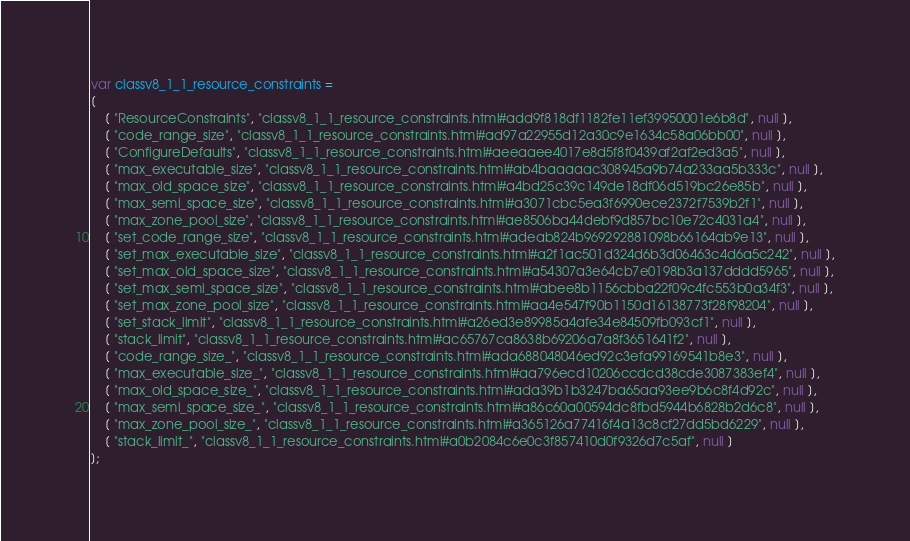<code> <loc_0><loc_0><loc_500><loc_500><_JavaScript_>var classv8_1_1_resource_constraints =
[
    [ "ResourceConstraints", "classv8_1_1_resource_constraints.html#add9f818df1182fe11ef39950001e6b8d", null ],
    [ "code_range_size", "classv8_1_1_resource_constraints.html#ad97a22955d12a30c9e1634c58a06bb00", null ],
    [ "ConfigureDefaults", "classv8_1_1_resource_constraints.html#aeeaaee4017e8d5f8f0439af2af2ed3a5", null ],
    [ "max_executable_size", "classv8_1_1_resource_constraints.html#ab4baaaaac308945a9b74a233aa5b333c", null ],
    [ "max_old_space_size", "classv8_1_1_resource_constraints.html#a4bd25c39c149de18df06d519bc26e85b", null ],
    [ "max_semi_space_size", "classv8_1_1_resource_constraints.html#a3071cbc5ea3f6990ece2372f7539b2f1", null ],
    [ "max_zone_pool_size", "classv8_1_1_resource_constraints.html#ae8506ba44debf9d857bc10e72c4031a4", null ],
    [ "set_code_range_size", "classv8_1_1_resource_constraints.html#adeab824b969292881098b66164ab9e13", null ],
    [ "set_max_executable_size", "classv8_1_1_resource_constraints.html#a2f1ac501d324d6b3d06463c4d6a5c242", null ],
    [ "set_max_old_space_size", "classv8_1_1_resource_constraints.html#a54307a3e64cb7e0198b3a137dddd5965", null ],
    [ "set_max_semi_space_size", "classv8_1_1_resource_constraints.html#abee8b1156cbba22f09c4fc553b0a34f3", null ],
    [ "set_max_zone_pool_size", "classv8_1_1_resource_constraints.html#aa4e547f90b1150d16138773f28f98204", null ],
    [ "set_stack_limit", "classv8_1_1_resource_constraints.html#a26ed3e89985a4afe34e84509fb093cf1", null ],
    [ "stack_limit", "classv8_1_1_resource_constraints.html#ac65767ca8638b69206a7a8f3651641f2", null ],
    [ "code_range_size_", "classv8_1_1_resource_constraints.html#ada688048046ed92c3efa99169541b8e3", null ],
    [ "max_executable_size_", "classv8_1_1_resource_constraints.html#aa796ecd10206ccdcd38cde3087383ef4", null ],
    [ "max_old_space_size_", "classv8_1_1_resource_constraints.html#ada39b1b3247ba65aa93ee9b6c8f4d92c", null ],
    [ "max_semi_space_size_", "classv8_1_1_resource_constraints.html#a86c60a00594dc8fbd5944b6828b2d6c8", null ],
    [ "max_zone_pool_size_", "classv8_1_1_resource_constraints.html#a365126a77416f4a13c8cf27dd5bd6229", null ],
    [ "stack_limit_", "classv8_1_1_resource_constraints.html#a0b2084c6e0c3f857410d0f9326d7c5af", null ]
];</code> 